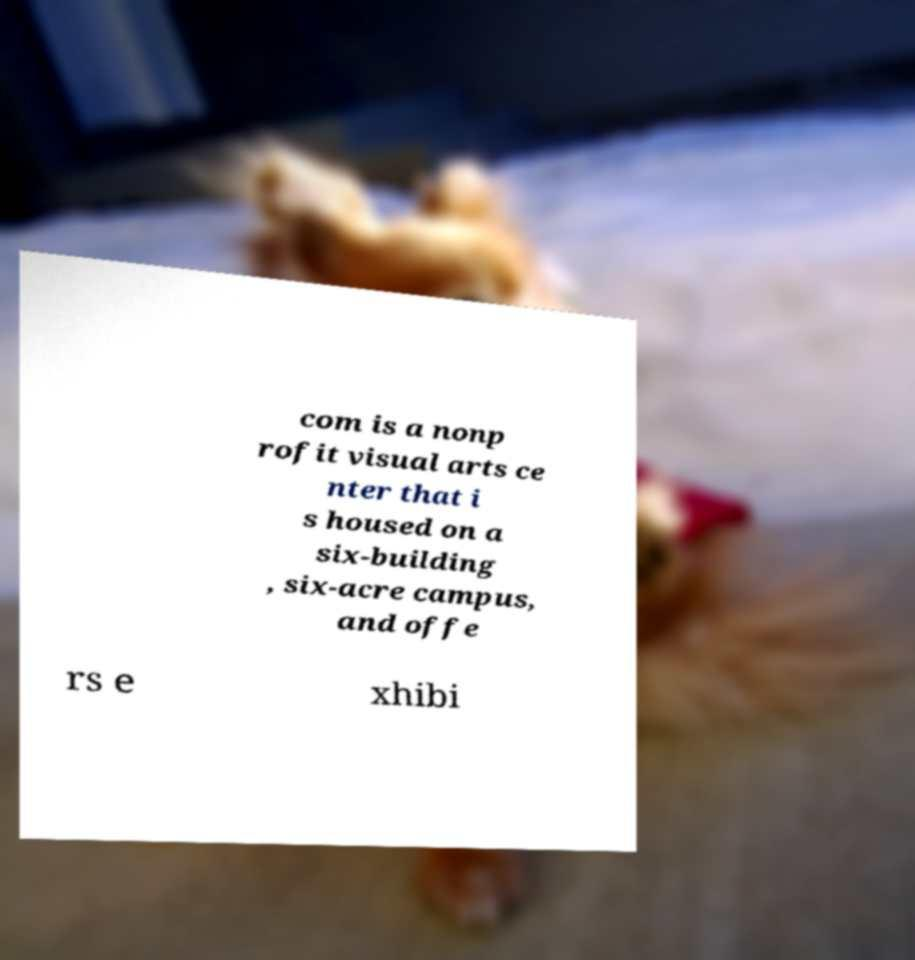I need the written content from this picture converted into text. Can you do that? com is a nonp rofit visual arts ce nter that i s housed on a six-building , six-acre campus, and offe rs e xhibi 